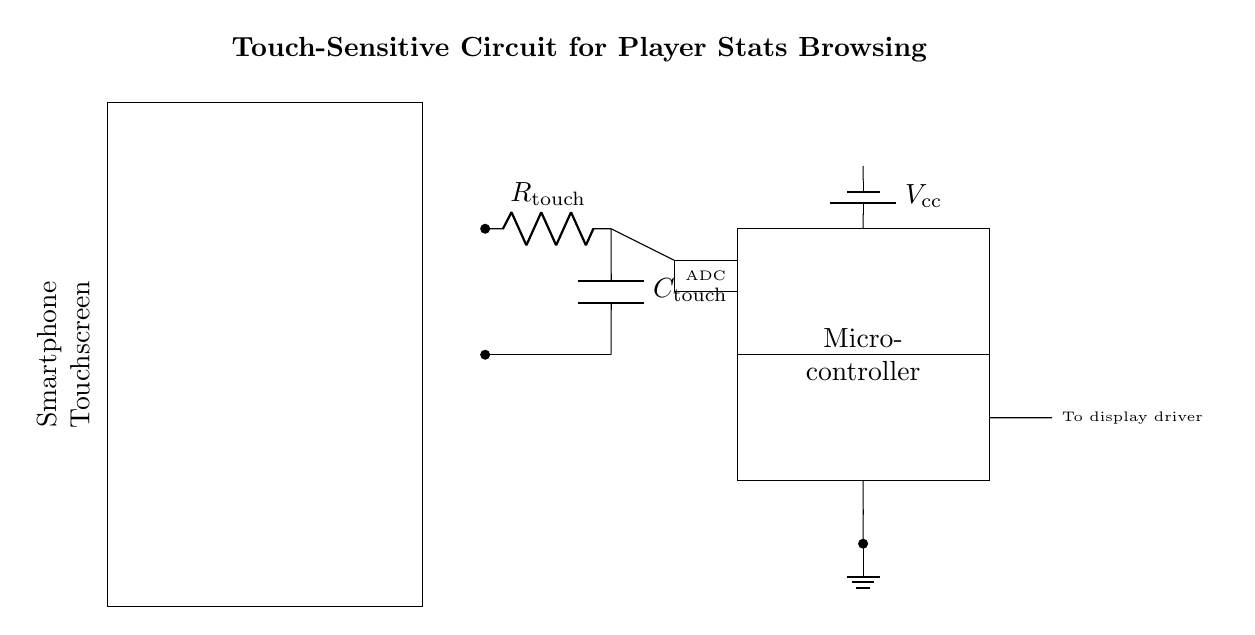What is the primary component responsible for touch sensing? The primary component responsible for touch sensing is the touch sensor, denoted by the resistor and capacitor in the diagram. They work together to detect changes in capacitance when a user touches the screen.
Answer: touch sensor What is the function of the microcontroller in this circuit? The microcontroller is responsible for processing the signals from the touch sensor, performing calculations, and controlling the output to the display based on user interactions.
Answer: processing signals How many major components are in this circuit? The circuit contains five major components: the touchscreen, touch sensor, microcontroller, ADC, and power supply.
Answer: five What does the ADC stand for in this circuit? The ADC stands for Analog-to-Digital Converter, which converts the analog signals from the touch sensor into digital signals that the microcontroller can understand.
Answer: Analog-to-Digital Converter What is the purpose of the capacitor in the touch sensor? The capacitor in the touch sensor helps to store charge and allows the circuit to sense changes in touch input by affecting the timing and levels of the signal registered by the microcontroller.
Answer: store charge What is the voltage supply for the circuit? The voltage supply for the circuit is represented as Vcc, which is typically the main power supply voltage that powers all components in the circuit.
Answer: Vcc What type of circuit is depicted in the diagram? The circuit depicted in the diagram is a touch-sensitive input circuit, specifically designed for mobile devices to facilitate user interaction with the smartphone screen.
Answer: touch-sensitive input circuit 